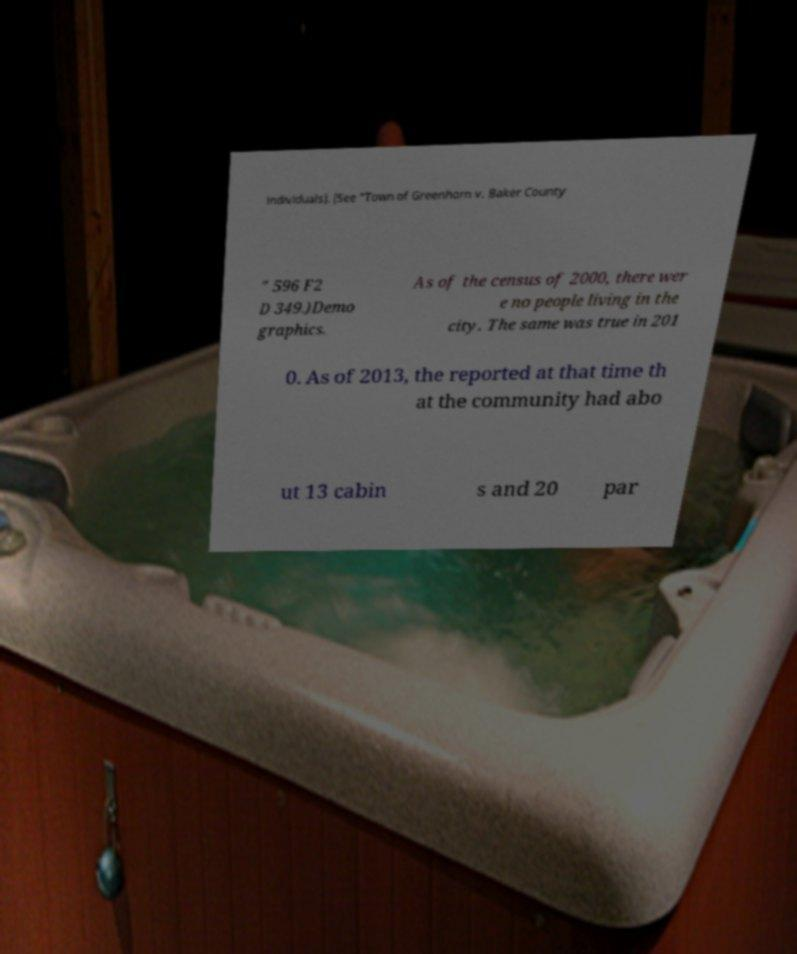I need the written content from this picture converted into text. Can you do that? individuals). (See "Town of Greenhorn v. Baker County " 596 F2 D 349.)Demo graphics. As of the census of 2000, there wer e no people living in the city. The same was true in 201 0. As of 2013, the reported at that time th at the community had abo ut 13 cabin s and 20 par 